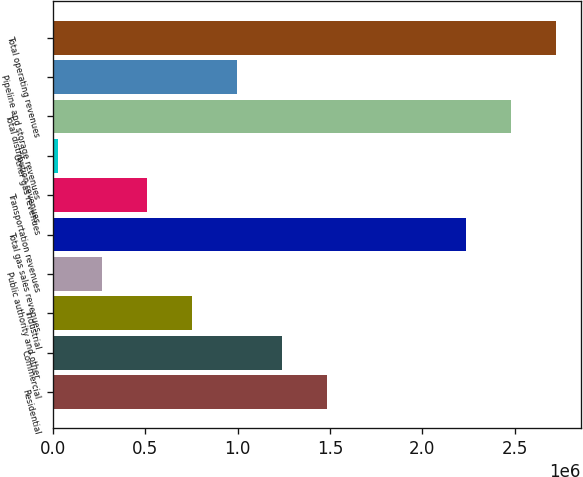Convert chart. <chart><loc_0><loc_0><loc_500><loc_500><bar_chart><fcel>Residential<fcel>Commercial<fcel>Industrial<fcel>Public authority and other<fcel>Total gas sales revenues<fcel>Transportation revenues<fcel>Other gas revenues<fcel>Total distribution revenues<fcel>Pipeline and storage revenues<fcel>Total operating revenues<nl><fcel>1.48276e+06<fcel>1.23979e+06<fcel>753852<fcel>267911<fcel>2.23677e+06<fcel>510882<fcel>24940<fcel>2.47974e+06<fcel>996823<fcel>2.72272e+06<nl></chart> 